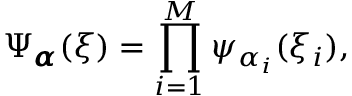Convert formula to latex. <formula><loc_0><loc_0><loc_500><loc_500>\Psi _ { { \pm b { \alpha } } } ( { \xi } ) = \prod _ { i = 1 } ^ { M } \psi _ { \alpha _ { i } } ( \xi _ { i } ) ,</formula> 